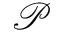<formula> <loc_0><loc_0><loc_500><loc_500>\mathcal { P }</formula> 